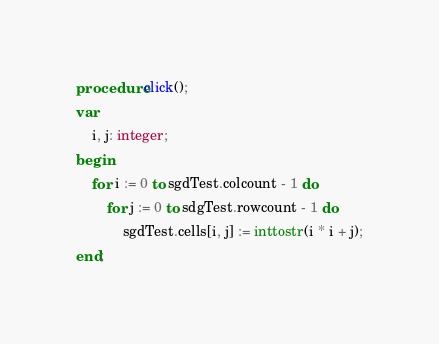<code> <loc_0><loc_0><loc_500><loc_500><_Pascal_>procedure click();
var
	i, j: integer;
begin
	for i := 0 to sgdTest.colcount - 1 do
		for j := 0 to sdgTest.rowcount - 1 do
			sgdTest.cells[i, j] := inttostr(i * i + j);
end;
</code> 